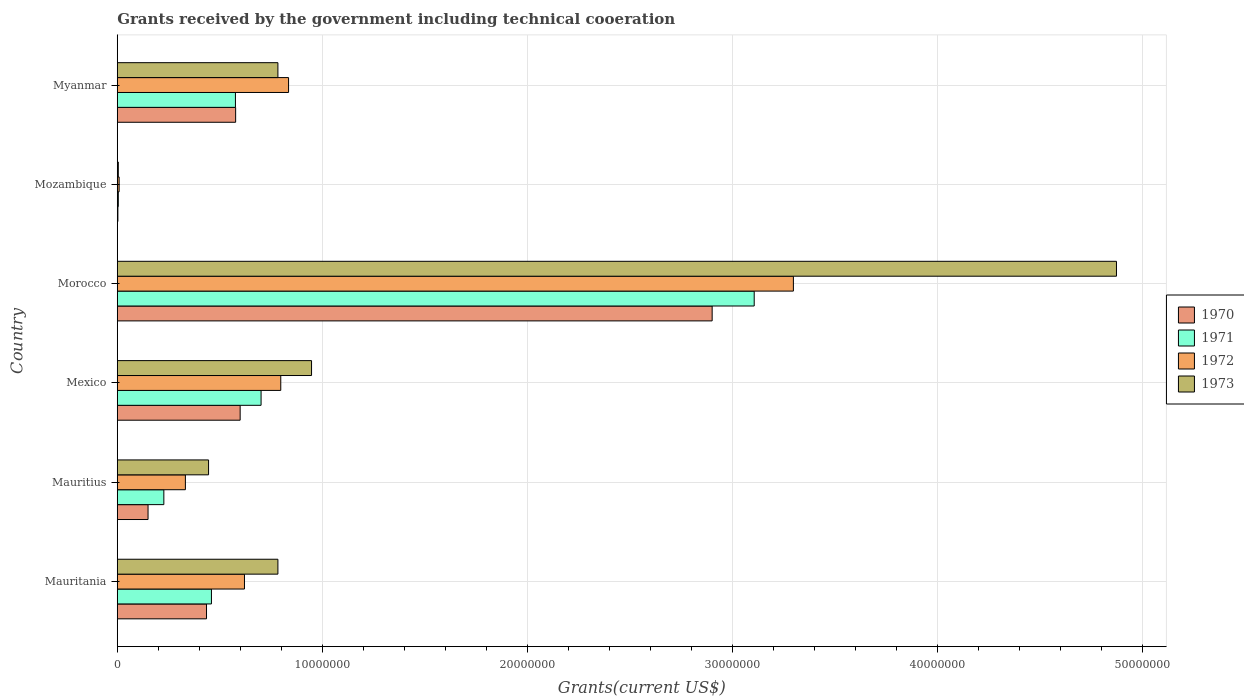How many groups of bars are there?
Keep it short and to the point. 6. Are the number of bars on each tick of the Y-axis equal?
Ensure brevity in your answer.  Yes. What is the label of the 3rd group of bars from the top?
Keep it short and to the point. Morocco. What is the total grants received by the government in 1971 in Mauritania?
Make the answer very short. 4.59e+06. Across all countries, what is the maximum total grants received by the government in 1971?
Offer a terse response. 3.10e+07. In which country was the total grants received by the government in 1972 maximum?
Offer a very short reply. Morocco. In which country was the total grants received by the government in 1971 minimum?
Give a very brief answer. Mozambique. What is the total total grants received by the government in 1971 in the graph?
Ensure brevity in your answer.  5.07e+07. What is the difference between the total grants received by the government in 1973 in Mozambique and that in Myanmar?
Your response must be concise. -7.78e+06. What is the difference between the total grants received by the government in 1973 in Morocco and the total grants received by the government in 1972 in Mauritania?
Keep it short and to the point. 4.25e+07. What is the average total grants received by the government in 1973 per country?
Provide a short and direct response. 1.31e+07. What is the difference between the total grants received by the government in 1972 and total grants received by the government in 1973 in Mexico?
Provide a short and direct response. -1.50e+06. What is the ratio of the total grants received by the government in 1973 in Mauritania to that in Mauritius?
Keep it short and to the point. 1.76. Is the total grants received by the government in 1970 in Mauritius less than that in Mexico?
Your response must be concise. Yes. Is the difference between the total grants received by the government in 1972 in Mauritania and Mauritius greater than the difference between the total grants received by the government in 1973 in Mauritania and Mauritius?
Give a very brief answer. No. What is the difference between the highest and the second highest total grants received by the government in 1970?
Offer a terse response. 2.30e+07. What is the difference between the highest and the lowest total grants received by the government in 1971?
Provide a succinct answer. 3.10e+07. Is the sum of the total grants received by the government in 1970 in Mozambique and Myanmar greater than the maximum total grants received by the government in 1971 across all countries?
Make the answer very short. No. Is it the case that in every country, the sum of the total grants received by the government in 1971 and total grants received by the government in 1970 is greater than the sum of total grants received by the government in 1972 and total grants received by the government in 1973?
Your response must be concise. No. What does the 2nd bar from the bottom in Mauritania represents?
Keep it short and to the point. 1971. Is it the case that in every country, the sum of the total grants received by the government in 1970 and total grants received by the government in 1971 is greater than the total grants received by the government in 1973?
Make the answer very short. No. How many bars are there?
Your answer should be very brief. 24. Are all the bars in the graph horizontal?
Provide a short and direct response. Yes. What is the difference between two consecutive major ticks on the X-axis?
Ensure brevity in your answer.  1.00e+07. Does the graph contain grids?
Your response must be concise. Yes. Where does the legend appear in the graph?
Give a very brief answer. Center right. What is the title of the graph?
Offer a terse response. Grants received by the government including technical cooeration. Does "1971" appear as one of the legend labels in the graph?
Provide a succinct answer. Yes. What is the label or title of the X-axis?
Provide a succinct answer. Grants(current US$). What is the Grants(current US$) in 1970 in Mauritania?
Your answer should be very brief. 4.35e+06. What is the Grants(current US$) in 1971 in Mauritania?
Keep it short and to the point. 4.59e+06. What is the Grants(current US$) in 1972 in Mauritania?
Ensure brevity in your answer.  6.20e+06. What is the Grants(current US$) of 1973 in Mauritania?
Ensure brevity in your answer.  7.83e+06. What is the Grants(current US$) in 1970 in Mauritius?
Provide a short and direct response. 1.50e+06. What is the Grants(current US$) of 1971 in Mauritius?
Your response must be concise. 2.27e+06. What is the Grants(current US$) in 1972 in Mauritius?
Your answer should be compact. 3.32e+06. What is the Grants(current US$) of 1973 in Mauritius?
Keep it short and to the point. 4.45e+06. What is the Grants(current US$) in 1970 in Mexico?
Your answer should be very brief. 5.99e+06. What is the Grants(current US$) of 1971 in Mexico?
Your answer should be compact. 7.01e+06. What is the Grants(current US$) in 1972 in Mexico?
Ensure brevity in your answer.  7.97e+06. What is the Grants(current US$) in 1973 in Mexico?
Give a very brief answer. 9.47e+06. What is the Grants(current US$) of 1970 in Morocco?
Provide a short and direct response. 2.90e+07. What is the Grants(current US$) of 1971 in Morocco?
Your response must be concise. 3.10e+07. What is the Grants(current US$) of 1972 in Morocco?
Offer a very short reply. 3.30e+07. What is the Grants(current US$) in 1973 in Morocco?
Offer a very short reply. 4.87e+07. What is the Grants(current US$) in 1972 in Mozambique?
Your answer should be very brief. 9.00e+04. What is the Grants(current US$) of 1973 in Mozambique?
Provide a succinct answer. 5.00e+04. What is the Grants(current US$) in 1970 in Myanmar?
Your response must be concise. 5.77e+06. What is the Grants(current US$) of 1971 in Myanmar?
Your answer should be compact. 5.76e+06. What is the Grants(current US$) in 1972 in Myanmar?
Provide a succinct answer. 8.35e+06. What is the Grants(current US$) in 1973 in Myanmar?
Ensure brevity in your answer.  7.83e+06. Across all countries, what is the maximum Grants(current US$) of 1970?
Your answer should be very brief. 2.90e+07. Across all countries, what is the maximum Grants(current US$) of 1971?
Your response must be concise. 3.10e+07. Across all countries, what is the maximum Grants(current US$) of 1972?
Make the answer very short. 3.30e+07. Across all countries, what is the maximum Grants(current US$) in 1973?
Give a very brief answer. 4.87e+07. Across all countries, what is the minimum Grants(current US$) of 1972?
Offer a terse response. 9.00e+04. What is the total Grants(current US$) of 1970 in the graph?
Your response must be concise. 4.66e+07. What is the total Grants(current US$) in 1971 in the graph?
Ensure brevity in your answer.  5.07e+07. What is the total Grants(current US$) in 1972 in the graph?
Keep it short and to the point. 5.89e+07. What is the total Grants(current US$) in 1973 in the graph?
Your response must be concise. 7.83e+07. What is the difference between the Grants(current US$) in 1970 in Mauritania and that in Mauritius?
Offer a very short reply. 2.85e+06. What is the difference between the Grants(current US$) in 1971 in Mauritania and that in Mauritius?
Make the answer very short. 2.32e+06. What is the difference between the Grants(current US$) in 1972 in Mauritania and that in Mauritius?
Make the answer very short. 2.88e+06. What is the difference between the Grants(current US$) of 1973 in Mauritania and that in Mauritius?
Your answer should be very brief. 3.38e+06. What is the difference between the Grants(current US$) of 1970 in Mauritania and that in Mexico?
Your response must be concise. -1.64e+06. What is the difference between the Grants(current US$) of 1971 in Mauritania and that in Mexico?
Provide a short and direct response. -2.42e+06. What is the difference between the Grants(current US$) in 1972 in Mauritania and that in Mexico?
Make the answer very short. -1.77e+06. What is the difference between the Grants(current US$) of 1973 in Mauritania and that in Mexico?
Provide a short and direct response. -1.64e+06. What is the difference between the Grants(current US$) in 1970 in Mauritania and that in Morocco?
Make the answer very short. -2.46e+07. What is the difference between the Grants(current US$) of 1971 in Mauritania and that in Morocco?
Your answer should be very brief. -2.65e+07. What is the difference between the Grants(current US$) in 1972 in Mauritania and that in Morocco?
Give a very brief answer. -2.68e+07. What is the difference between the Grants(current US$) in 1973 in Mauritania and that in Morocco?
Offer a terse response. -4.09e+07. What is the difference between the Grants(current US$) of 1970 in Mauritania and that in Mozambique?
Give a very brief answer. 4.32e+06. What is the difference between the Grants(current US$) of 1971 in Mauritania and that in Mozambique?
Keep it short and to the point. 4.54e+06. What is the difference between the Grants(current US$) of 1972 in Mauritania and that in Mozambique?
Provide a succinct answer. 6.11e+06. What is the difference between the Grants(current US$) in 1973 in Mauritania and that in Mozambique?
Make the answer very short. 7.78e+06. What is the difference between the Grants(current US$) of 1970 in Mauritania and that in Myanmar?
Offer a terse response. -1.42e+06. What is the difference between the Grants(current US$) in 1971 in Mauritania and that in Myanmar?
Ensure brevity in your answer.  -1.17e+06. What is the difference between the Grants(current US$) in 1972 in Mauritania and that in Myanmar?
Offer a terse response. -2.15e+06. What is the difference between the Grants(current US$) in 1970 in Mauritius and that in Mexico?
Your answer should be compact. -4.49e+06. What is the difference between the Grants(current US$) of 1971 in Mauritius and that in Mexico?
Provide a succinct answer. -4.74e+06. What is the difference between the Grants(current US$) of 1972 in Mauritius and that in Mexico?
Offer a very short reply. -4.65e+06. What is the difference between the Grants(current US$) of 1973 in Mauritius and that in Mexico?
Offer a very short reply. -5.02e+06. What is the difference between the Grants(current US$) in 1970 in Mauritius and that in Morocco?
Keep it short and to the point. -2.75e+07. What is the difference between the Grants(current US$) of 1971 in Mauritius and that in Morocco?
Ensure brevity in your answer.  -2.88e+07. What is the difference between the Grants(current US$) in 1972 in Mauritius and that in Morocco?
Make the answer very short. -2.96e+07. What is the difference between the Grants(current US$) of 1973 in Mauritius and that in Morocco?
Your answer should be compact. -4.43e+07. What is the difference between the Grants(current US$) of 1970 in Mauritius and that in Mozambique?
Your response must be concise. 1.47e+06. What is the difference between the Grants(current US$) of 1971 in Mauritius and that in Mozambique?
Offer a terse response. 2.22e+06. What is the difference between the Grants(current US$) of 1972 in Mauritius and that in Mozambique?
Your answer should be compact. 3.23e+06. What is the difference between the Grants(current US$) in 1973 in Mauritius and that in Mozambique?
Provide a succinct answer. 4.40e+06. What is the difference between the Grants(current US$) of 1970 in Mauritius and that in Myanmar?
Your response must be concise. -4.27e+06. What is the difference between the Grants(current US$) of 1971 in Mauritius and that in Myanmar?
Your answer should be compact. -3.49e+06. What is the difference between the Grants(current US$) of 1972 in Mauritius and that in Myanmar?
Keep it short and to the point. -5.03e+06. What is the difference between the Grants(current US$) of 1973 in Mauritius and that in Myanmar?
Give a very brief answer. -3.38e+06. What is the difference between the Grants(current US$) of 1970 in Mexico and that in Morocco?
Your answer should be compact. -2.30e+07. What is the difference between the Grants(current US$) of 1971 in Mexico and that in Morocco?
Provide a succinct answer. -2.40e+07. What is the difference between the Grants(current US$) of 1972 in Mexico and that in Morocco?
Your response must be concise. -2.50e+07. What is the difference between the Grants(current US$) in 1973 in Mexico and that in Morocco?
Provide a succinct answer. -3.92e+07. What is the difference between the Grants(current US$) in 1970 in Mexico and that in Mozambique?
Your answer should be very brief. 5.96e+06. What is the difference between the Grants(current US$) in 1971 in Mexico and that in Mozambique?
Provide a short and direct response. 6.96e+06. What is the difference between the Grants(current US$) in 1972 in Mexico and that in Mozambique?
Offer a terse response. 7.88e+06. What is the difference between the Grants(current US$) of 1973 in Mexico and that in Mozambique?
Offer a terse response. 9.42e+06. What is the difference between the Grants(current US$) of 1971 in Mexico and that in Myanmar?
Your answer should be compact. 1.25e+06. What is the difference between the Grants(current US$) of 1972 in Mexico and that in Myanmar?
Provide a short and direct response. -3.80e+05. What is the difference between the Grants(current US$) of 1973 in Mexico and that in Myanmar?
Your answer should be very brief. 1.64e+06. What is the difference between the Grants(current US$) of 1970 in Morocco and that in Mozambique?
Ensure brevity in your answer.  2.90e+07. What is the difference between the Grants(current US$) in 1971 in Morocco and that in Mozambique?
Your answer should be very brief. 3.10e+07. What is the difference between the Grants(current US$) of 1972 in Morocco and that in Mozambique?
Provide a succinct answer. 3.29e+07. What is the difference between the Grants(current US$) in 1973 in Morocco and that in Mozambique?
Make the answer very short. 4.87e+07. What is the difference between the Grants(current US$) in 1970 in Morocco and that in Myanmar?
Offer a very short reply. 2.32e+07. What is the difference between the Grants(current US$) in 1971 in Morocco and that in Myanmar?
Make the answer very short. 2.53e+07. What is the difference between the Grants(current US$) of 1972 in Morocco and that in Myanmar?
Your answer should be very brief. 2.46e+07. What is the difference between the Grants(current US$) of 1973 in Morocco and that in Myanmar?
Give a very brief answer. 4.09e+07. What is the difference between the Grants(current US$) of 1970 in Mozambique and that in Myanmar?
Offer a very short reply. -5.74e+06. What is the difference between the Grants(current US$) in 1971 in Mozambique and that in Myanmar?
Your response must be concise. -5.71e+06. What is the difference between the Grants(current US$) of 1972 in Mozambique and that in Myanmar?
Keep it short and to the point. -8.26e+06. What is the difference between the Grants(current US$) of 1973 in Mozambique and that in Myanmar?
Your answer should be compact. -7.78e+06. What is the difference between the Grants(current US$) in 1970 in Mauritania and the Grants(current US$) in 1971 in Mauritius?
Your answer should be compact. 2.08e+06. What is the difference between the Grants(current US$) of 1970 in Mauritania and the Grants(current US$) of 1972 in Mauritius?
Give a very brief answer. 1.03e+06. What is the difference between the Grants(current US$) in 1970 in Mauritania and the Grants(current US$) in 1973 in Mauritius?
Provide a short and direct response. -1.00e+05. What is the difference between the Grants(current US$) of 1971 in Mauritania and the Grants(current US$) of 1972 in Mauritius?
Your answer should be compact. 1.27e+06. What is the difference between the Grants(current US$) of 1971 in Mauritania and the Grants(current US$) of 1973 in Mauritius?
Give a very brief answer. 1.40e+05. What is the difference between the Grants(current US$) in 1972 in Mauritania and the Grants(current US$) in 1973 in Mauritius?
Your response must be concise. 1.75e+06. What is the difference between the Grants(current US$) of 1970 in Mauritania and the Grants(current US$) of 1971 in Mexico?
Make the answer very short. -2.66e+06. What is the difference between the Grants(current US$) in 1970 in Mauritania and the Grants(current US$) in 1972 in Mexico?
Offer a very short reply. -3.62e+06. What is the difference between the Grants(current US$) of 1970 in Mauritania and the Grants(current US$) of 1973 in Mexico?
Keep it short and to the point. -5.12e+06. What is the difference between the Grants(current US$) of 1971 in Mauritania and the Grants(current US$) of 1972 in Mexico?
Offer a very short reply. -3.38e+06. What is the difference between the Grants(current US$) in 1971 in Mauritania and the Grants(current US$) in 1973 in Mexico?
Offer a very short reply. -4.88e+06. What is the difference between the Grants(current US$) of 1972 in Mauritania and the Grants(current US$) of 1973 in Mexico?
Give a very brief answer. -3.27e+06. What is the difference between the Grants(current US$) of 1970 in Mauritania and the Grants(current US$) of 1971 in Morocco?
Provide a succinct answer. -2.67e+07. What is the difference between the Grants(current US$) in 1970 in Mauritania and the Grants(current US$) in 1972 in Morocco?
Ensure brevity in your answer.  -2.86e+07. What is the difference between the Grants(current US$) of 1970 in Mauritania and the Grants(current US$) of 1973 in Morocco?
Give a very brief answer. -4.44e+07. What is the difference between the Grants(current US$) in 1971 in Mauritania and the Grants(current US$) in 1972 in Morocco?
Offer a terse response. -2.84e+07. What is the difference between the Grants(current US$) in 1971 in Mauritania and the Grants(current US$) in 1973 in Morocco?
Provide a short and direct response. -4.41e+07. What is the difference between the Grants(current US$) of 1972 in Mauritania and the Grants(current US$) of 1973 in Morocco?
Your answer should be very brief. -4.25e+07. What is the difference between the Grants(current US$) in 1970 in Mauritania and the Grants(current US$) in 1971 in Mozambique?
Ensure brevity in your answer.  4.30e+06. What is the difference between the Grants(current US$) of 1970 in Mauritania and the Grants(current US$) of 1972 in Mozambique?
Your response must be concise. 4.26e+06. What is the difference between the Grants(current US$) of 1970 in Mauritania and the Grants(current US$) of 1973 in Mozambique?
Offer a very short reply. 4.30e+06. What is the difference between the Grants(current US$) in 1971 in Mauritania and the Grants(current US$) in 1972 in Mozambique?
Offer a terse response. 4.50e+06. What is the difference between the Grants(current US$) in 1971 in Mauritania and the Grants(current US$) in 1973 in Mozambique?
Your response must be concise. 4.54e+06. What is the difference between the Grants(current US$) in 1972 in Mauritania and the Grants(current US$) in 1973 in Mozambique?
Ensure brevity in your answer.  6.15e+06. What is the difference between the Grants(current US$) in 1970 in Mauritania and the Grants(current US$) in 1971 in Myanmar?
Ensure brevity in your answer.  -1.41e+06. What is the difference between the Grants(current US$) of 1970 in Mauritania and the Grants(current US$) of 1973 in Myanmar?
Ensure brevity in your answer.  -3.48e+06. What is the difference between the Grants(current US$) in 1971 in Mauritania and the Grants(current US$) in 1972 in Myanmar?
Your response must be concise. -3.76e+06. What is the difference between the Grants(current US$) of 1971 in Mauritania and the Grants(current US$) of 1973 in Myanmar?
Provide a short and direct response. -3.24e+06. What is the difference between the Grants(current US$) of 1972 in Mauritania and the Grants(current US$) of 1973 in Myanmar?
Your answer should be compact. -1.63e+06. What is the difference between the Grants(current US$) of 1970 in Mauritius and the Grants(current US$) of 1971 in Mexico?
Give a very brief answer. -5.51e+06. What is the difference between the Grants(current US$) in 1970 in Mauritius and the Grants(current US$) in 1972 in Mexico?
Your response must be concise. -6.47e+06. What is the difference between the Grants(current US$) of 1970 in Mauritius and the Grants(current US$) of 1973 in Mexico?
Make the answer very short. -7.97e+06. What is the difference between the Grants(current US$) in 1971 in Mauritius and the Grants(current US$) in 1972 in Mexico?
Your answer should be very brief. -5.70e+06. What is the difference between the Grants(current US$) of 1971 in Mauritius and the Grants(current US$) of 1973 in Mexico?
Make the answer very short. -7.20e+06. What is the difference between the Grants(current US$) in 1972 in Mauritius and the Grants(current US$) in 1973 in Mexico?
Your answer should be compact. -6.15e+06. What is the difference between the Grants(current US$) of 1970 in Mauritius and the Grants(current US$) of 1971 in Morocco?
Make the answer very short. -2.96e+07. What is the difference between the Grants(current US$) in 1970 in Mauritius and the Grants(current US$) in 1972 in Morocco?
Provide a short and direct response. -3.15e+07. What is the difference between the Grants(current US$) in 1970 in Mauritius and the Grants(current US$) in 1973 in Morocco?
Give a very brief answer. -4.72e+07. What is the difference between the Grants(current US$) of 1971 in Mauritius and the Grants(current US$) of 1972 in Morocco?
Offer a terse response. -3.07e+07. What is the difference between the Grants(current US$) of 1971 in Mauritius and the Grants(current US$) of 1973 in Morocco?
Your response must be concise. -4.64e+07. What is the difference between the Grants(current US$) in 1972 in Mauritius and the Grants(current US$) in 1973 in Morocco?
Provide a succinct answer. -4.54e+07. What is the difference between the Grants(current US$) in 1970 in Mauritius and the Grants(current US$) in 1971 in Mozambique?
Offer a very short reply. 1.45e+06. What is the difference between the Grants(current US$) in 1970 in Mauritius and the Grants(current US$) in 1972 in Mozambique?
Keep it short and to the point. 1.41e+06. What is the difference between the Grants(current US$) of 1970 in Mauritius and the Grants(current US$) of 1973 in Mozambique?
Your answer should be very brief. 1.45e+06. What is the difference between the Grants(current US$) of 1971 in Mauritius and the Grants(current US$) of 1972 in Mozambique?
Ensure brevity in your answer.  2.18e+06. What is the difference between the Grants(current US$) in 1971 in Mauritius and the Grants(current US$) in 1973 in Mozambique?
Ensure brevity in your answer.  2.22e+06. What is the difference between the Grants(current US$) of 1972 in Mauritius and the Grants(current US$) of 1973 in Mozambique?
Offer a very short reply. 3.27e+06. What is the difference between the Grants(current US$) of 1970 in Mauritius and the Grants(current US$) of 1971 in Myanmar?
Provide a short and direct response. -4.26e+06. What is the difference between the Grants(current US$) in 1970 in Mauritius and the Grants(current US$) in 1972 in Myanmar?
Give a very brief answer. -6.85e+06. What is the difference between the Grants(current US$) of 1970 in Mauritius and the Grants(current US$) of 1973 in Myanmar?
Ensure brevity in your answer.  -6.33e+06. What is the difference between the Grants(current US$) in 1971 in Mauritius and the Grants(current US$) in 1972 in Myanmar?
Offer a terse response. -6.08e+06. What is the difference between the Grants(current US$) of 1971 in Mauritius and the Grants(current US$) of 1973 in Myanmar?
Provide a short and direct response. -5.56e+06. What is the difference between the Grants(current US$) in 1972 in Mauritius and the Grants(current US$) in 1973 in Myanmar?
Provide a succinct answer. -4.51e+06. What is the difference between the Grants(current US$) in 1970 in Mexico and the Grants(current US$) in 1971 in Morocco?
Your answer should be compact. -2.51e+07. What is the difference between the Grants(current US$) in 1970 in Mexico and the Grants(current US$) in 1972 in Morocco?
Provide a short and direct response. -2.70e+07. What is the difference between the Grants(current US$) in 1970 in Mexico and the Grants(current US$) in 1973 in Morocco?
Your answer should be very brief. -4.27e+07. What is the difference between the Grants(current US$) of 1971 in Mexico and the Grants(current US$) of 1972 in Morocco?
Your answer should be very brief. -2.60e+07. What is the difference between the Grants(current US$) in 1971 in Mexico and the Grants(current US$) in 1973 in Morocco?
Keep it short and to the point. -4.17e+07. What is the difference between the Grants(current US$) of 1972 in Mexico and the Grants(current US$) of 1973 in Morocco?
Provide a succinct answer. -4.07e+07. What is the difference between the Grants(current US$) of 1970 in Mexico and the Grants(current US$) of 1971 in Mozambique?
Give a very brief answer. 5.94e+06. What is the difference between the Grants(current US$) in 1970 in Mexico and the Grants(current US$) in 1972 in Mozambique?
Provide a succinct answer. 5.90e+06. What is the difference between the Grants(current US$) in 1970 in Mexico and the Grants(current US$) in 1973 in Mozambique?
Your response must be concise. 5.94e+06. What is the difference between the Grants(current US$) of 1971 in Mexico and the Grants(current US$) of 1972 in Mozambique?
Keep it short and to the point. 6.92e+06. What is the difference between the Grants(current US$) in 1971 in Mexico and the Grants(current US$) in 1973 in Mozambique?
Keep it short and to the point. 6.96e+06. What is the difference between the Grants(current US$) in 1972 in Mexico and the Grants(current US$) in 1973 in Mozambique?
Offer a very short reply. 7.92e+06. What is the difference between the Grants(current US$) in 1970 in Mexico and the Grants(current US$) in 1972 in Myanmar?
Offer a very short reply. -2.36e+06. What is the difference between the Grants(current US$) of 1970 in Mexico and the Grants(current US$) of 1973 in Myanmar?
Your answer should be very brief. -1.84e+06. What is the difference between the Grants(current US$) of 1971 in Mexico and the Grants(current US$) of 1972 in Myanmar?
Make the answer very short. -1.34e+06. What is the difference between the Grants(current US$) of 1971 in Mexico and the Grants(current US$) of 1973 in Myanmar?
Your answer should be very brief. -8.20e+05. What is the difference between the Grants(current US$) in 1972 in Mexico and the Grants(current US$) in 1973 in Myanmar?
Your response must be concise. 1.40e+05. What is the difference between the Grants(current US$) in 1970 in Morocco and the Grants(current US$) in 1971 in Mozambique?
Give a very brief answer. 2.90e+07. What is the difference between the Grants(current US$) of 1970 in Morocco and the Grants(current US$) of 1972 in Mozambique?
Your answer should be very brief. 2.89e+07. What is the difference between the Grants(current US$) in 1970 in Morocco and the Grants(current US$) in 1973 in Mozambique?
Your answer should be very brief. 2.90e+07. What is the difference between the Grants(current US$) of 1971 in Morocco and the Grants(current US$) of 1972 in Mozambique?
Make the answer very short. 3.10e+07. What is the difference between the Grants(current US$) in 1971 in Morocco and the Grants(current US$) in 1973 in Mozambique?
Offer a very short reply. 3.10e+07. What is the difference between the Grants(current US$) in 1972 in Morocco and the Grants(current US$) in 1973 in Mozambique?
Make the answer very short. 3.29e+07. What is the difference between the Grants(current US$) of 1970 in Morocco and the Grants(current US$) of 1971 in Myanmar?
Offer a terse response. 2.32e+07. What is the difference between the Grants(current US$) in 1970 in Morocco and the Grants(current US$) in 1972 in Myanmar?
Your response must be concise. 2.06e+07. What is the difference between the Grants(current US$) of 1970 in Morocco and the Grants(current US$) of 1973 in Myanmar?
Your answer should be very brief. 2.12e+07. What is the difference between the Grants(current US$) in 1971 in Morocco and the Grants(current US$) in 1972 in Myanmar?
Offer a terse response. 2.27e+07. What is the difference between the Grants(current US$) of 1971 in Morocco and the Grants(current US$) of 1973 in Myanmar?
Your response must be concise. 2.32e+07. What is the difference between the Grants(current US$) in 1972 in Morocco and the Grants(current US$) in 1973 in Myanmar?
Provide a short and direct response. 2.51e+07. What is the difference between the Grants(current US$) of 1970 in Mozambique and the Grants(current US$) of 1971 in Myanmar?
Your answer should be very brief. -5.73e+06. What is the difference between the Grants(current US$) in 1970 in Mozambique and the Grants(current US$) in 1972 in Myanmar?
Offer a terse response. -8.32e+06. What is the difference between the Grants(current US$) in 1970 in Mozambique and the Grants(current US$) in 1973 in Myanmar?
Your answer should be compact. -7.80e+06. What is the difference between the Grants(current US$) of 1971 in Mozambique and the Grants(current US$) of 1972 in Myanmar?
Ensure brevity in your answer.  -8.30e+06. What is the difference between the Grants(current US$) in 1971 in Mozambique and the Grants(current US$) in 1973 in Myanmar?
Offer a very short reply. -7.78e+06. What is the difference between the Grants(current US$) of 1972 in Mozambique and the Grants(current US$) of 1973 in Myanmar?
Offer a very short reply. -7.74e+06. What is the average Grants(current US$) of 1970 per country?
Offer a very short reply. 7.77e+06. What is the average Grants(current US$) in 1971 per country?
Offer a terse response. 8.46e+06. What is the average Grants(current US$) in 1972 per country?
Ensure brevity in your answer.  9.82e+06. What is the average Grants(current US$) in 1973 per country?
Offer a terse response. 1.31e+07. What is the difference between the Grants(current US$) in 1970 and Grants(current US$) in 1971 in Mauritania?
Ensure brevity in your answer.  -2.40e+05. What is the difference between the Grants(current US$) of 1970 and Grants(current US$) of 1972 in Mauritania?
Provide a short and direct response. -1.85e+06. What is the difference between the Grants(current US$) in 1970 and Grants(current US$) in 1973 in Mauritania?
Make the answer very short. -3.48e+06. What is the difference between the Grants(current US$) in 1971 and Grants(current US$) in 1972 in Mauritania?
Your answer should be compact. -1.61e+06. What is the difference between the Grants(current US$) of 1971 and Grants(current US$) of 1973 in Mauritania?
Ensure brevity in your answer.  -3.24e+06. What is the difference between the Grants(current US$) of 1972 and Grants(current US$) of 1973 in Mauritania?
Keep it short and to the point. -1.63e+06. What is the difference between the Grants(current US$) of 1970 and Grants(current US$) of 1971 in Mauritius?
Your response must be concise. -7.70e+05. What is the difference between the Grants(current US$) in 1970 and Grants(current US$) in 1972 in Mauritius?
Your response must be concise. -1.82e+06. What is the difference between the Grants(current US$) of 1970 and Grants(current US$) of 1973 in Mauritius?
Keep it short and to the point. -2.95e+06. What is the difference between the Grants(current US$) in 1971 and Grants(current US$) in 1972 in Mauritius?
Give a very brief answer. -1.05e+06. What is the difference between the Grants(current US$) in 1971 and Grants(current US$) in 1973 in Mauritius?
Keep it short and to the point. -2.18e+06. What is the difference between the Grants(current US$) in 1972 and Grants(current US$) in 1973 in Mauritius?
Your answer should be very brief. -1.13e+06. What is the difference between the Grants(current US$) in 1970 and Grants(current US$) in 1971 in Mexico?
Give a very brief answer. -1.02e+06. What is the difference between the Grants(current US$) of 1970 and Grants(current US$) of 1972 in Mexico?
Your response must be concise. -1.98e+06. What is the difference between the Grants(current US$) of 1970 and Grants(current US$) of 1973 in Mexico?
Your answer should be very brief. -3.48e+06. What is the difference between the Grants(current US$) in 1971 and Grants(current US$) in 1972 in Mexico?
Offer a terse response. -9.60e+05. What is the difference between the Grants(current US$) of 1971 and Grants(current US$) of 1973 in Mexico?
Provide a succinct answer. -2.46e+06. What is the difference between the Grants(current US$) in 1972 and Grants(current US$) in 1973 in Mexico?
Your answer should be compact. -1.50e+06. What is the difference between the Grants(current US$) in 1970 and Grants(current US$) in 1971 in Morocco?
Keep it short and to the point. -2.05e+06. What is the difference between the Grants(current US$) in 1970 and Grants(current US$) in 1972 in Morocco?
Offer a terse response. -3.96e+06. What is the difference between the Grants(current US$) of 1970 and Grants(current US$) of 1973 in Morocco?
Keep it short and to the point. -1.97e+07. What is the difference between the Grants(current US$) in 1971 and Grants(current US$) in 1972 in Morocco?
Your response must be concise. -1.91e+06. What is the difference between the Grants(current US$) in 1971 and Grants(current US$) in 1973 in Morocco?
Give a very brief answer. -1.77e+07. What is the difference between the Grants(current US$) in 1972 and Grants(current US$) in 1973 in Morocco?
Ensure brevity in your answer.  -1.58e+07. What is the difference between the Grants(current US$) in 1970 and Grants(current US$) in 1972 in Mozambique?
Your answer should be compact. -6.00e+04. What is the difference between the Grants(current US$) in 1970 and Grants(current US$) in 1972 in Myanmar?
Offer a terse response. -2.58e+06. What is the difference between the Grants(current US$) of 1970 and Grants(current US$) of 1973 in Myanmar?
Keep it short and to the point. -2.06e+06. What is the difference between the Grants(current US$) of 1971 and Grants(current US$) of 1972 in Myanmar?
Offer a very short reply. -2.59e+06. What is the difference between the Grants(current US$) in 1971 and Grants(current US$) in 1973 in Myanmar?
Keep it short and to the point. -2.07e+06. What is the difference between the Grants(current US$) of 1972 and Grants(current US$) of 1973 in Myanmar?
Your answer should be compact. 5.20e+05. What is the ratio of the Grants(current US$) of 1971 in Mauritania to that in Mauritius?
Provide a short and direct response. 2.02. What is the ratio of the Grants(current US$) of 1972 in Mauritania to that in Mauritius?
Your response must be concise. 1.87. What is the ratio of the Grants(current US$) in 1973 in Mauritania to that in Mauritius?
Your answer should be very brief. 1.76. What is the ratio of the Grants(current US$) in 1970 in Mauritania to that in Mexico?
Keep it short and to the point. 0.73. What is the ratio of the Grants(current US$) in 1971 in Mauritania to that in Mexico?
Offer a terse response. 0.65. What is the ratio of the Grants(current US$) of 1972 in Mauritania to that in Mexico?
Keep it short and to the point. 0.78. What is the ratio of the Grants(current US$) of 1973 in Mauritania to that in Mexico?
Ensure brevity in your answer.  0.83. What is the ratio of the Grants(current US$) of 1971 in Mauritania to that in Morocco?
Your answer should be compact. 0.15. What is the ratio of the Grants(current US$) in 1972 in Mauritania to that in Morocco?
Provide a succinct answer. 0.19. What is the ratio of the Grants(current US$) in 1973 in Mauritania to that in Morocco?
Keep it short and to the point. 0.16. What is the ratio of the Grants(current US$) in 1970 in Mauritania to that in Mozambique?
Your answer should be very brief. 145. What is the ratio of the Grants(current US$) in 1971 in Mauritania to that in Mozambique?
Ensure brevity in your answer.  91.8. What is the ratio of the Grants(current US$) in 1972 in Mauritania to that in Mozambique?
Your response must be concise. 68.89. What is the ratio of the Grants(current US$) of 1973 in Mauritania to that in Mozambique?
Offer a terse response. 156.6. What is the ratio of the Grants(current US$) in 1970 in Mauritania to that in Myanmar?
Ensure brevity in your answer.  0.75. What is the ratio of the Grants(current US$) in 1971 in Mauritania to that in Myanmar?
Give a very brief answer. 0.8. What is the ratio of the Grants(current US$) in 1972 in Mauritania to that in Myanmar?
Make the answer very short. 0.74. What is the ratio of the Grants(current US$) in 1970 in Mauritius to that in Mexico?
Give a very brief answer. 0.25. What is the ratio of the Grants(current US$) in 1971 in Mauritius to that in Mexico?
Your answer should be compact. 0.32. What is the ratio of the Grants(current US$) of 1972 in Mauritius to that in Mexico?
Give a very brief answer. 0.42. What is the ratio of the Grants(current US$) in 1973 in Mauritius to that in Mexico?
Offer a very short reply. 0.47. What is the ratio of the Grants(current US$) of 1970 in Mauritius to that in Morocco?
Offer a very short reply. 0.05. What is the ratio of the Grants(current US$) in 1971 in Mauritius to that in Morocco?
Your answer should be very brief. 0.07. What is the ratio of the Grants(current US$) of 1972 in Mauritius to that in Morocco?
Your answer should be very brief. 0.1. What is the ratio of the Grants(current US$) in 1973 in Mauritius to that in Morocco?
Provide a short and direct response. 0.09. What is the ratio of the Grants(current US$) in 1971 in Mauritius to that in Mozambique?
Give a very brief answer. 45.4. What is the ratio of the Grants(current US$) in 1972 in Mauritius to that in Mozambique?
Make the answer very short. 36.89. What is the ratio of the Grants(current US$) of 1973 in Mauritius to that in Mozambique?
Your answer should be compact. 89. What is the ratio of the Grants(current US$) in 1970 in Mauritius to that in Myanmar?
Give a very brief answer. 0.26. What is the ratio of the Grants(current US$) of 1971 in Mauritius to that in Myanmar?
Provide a short and direct response. 0.39. What is the ratio of the Grants(current US$) of 1972 in Mauritius to that in Myanmar?
Offer a terse response. 0.4. What is the ratio of the Grants(current US$) in 1973 in Mauritius to that in Myanmar?
Your answer should be very brief. 0.57. What is the ratio of the Grants(current US$) of 1970 in Mexico to that in Morocco?
Keep it short and to the point. 0.21. What is the ratio of the Grants(current US$) in 1971 in Mexico to that in Morocco?
Your response must be concise. 0.23. What is the ratio of the Grants(current US$) of 1972 in Mexico to that in Morocco?
Offer a terse response. 0.24. What is the ratio of the Grants(current US$) of 1973 in Mexico to that in Morocco?
Offer a terse response. 0.19. What is the ratio of the Grants(current US$) of 1970 in Mexico to that in Mozambique?
Provide a short and direct response. 199.67. What is the ratio of the Grants(current US$) in 1971 in Mexico to that in Mozambique?
Provide a succinct answer. 140.2. What is the ratio of the Grants(current US$) of 1972 in Mexico to that in Mozambique?
Give a very brief answer. 88.56. What is the ratio of the Grants(current US$) of 1973 in Mexico to that in Mozambique?
Your answer should be compact. 189.4. What is the ratio of the Grants(current US$) in 1970 in Mexico to that in Myanmar?
Provide a short and direct response. 1.04. What is the ratio of the Grants(current US$) in 1971 in Mexico to that in Myanmar?
Provide a succinct answer. 1.22. What is the ratio of the Grants(current US$) of 1972 in Mexico to that in Myanmar?
Provide a succinct answer. 0.95. What is the ratio of the Grants(current US$) in 1973 in Mexico to that in Myanmar?
Ensure brevity in your answer.  1.21. What is the ratio of the Grants(current US$) of 1970 in Morocco to that in Mozambique?
Provide a succinct answer. 966.67. What is the ratio of the Grants(current US$) of 1971 in Morocco to that in Mozambique?
Your answer should be compact. 621. What is the ratio of the Grants(current US$) of 1972 in Morocco to that in Mozambique?
Ensure brevity in your answer.  366.22. What is the ratio of the Grants(current US$) of 1973 in Morocco to that in Mozambique?
Your response must be concise. 974.2. What is the ratio of the Grants(current US$) of 1970 in Morocco to that in Myanmar?
Offer a very short reply. 5.03. What is the ratio of the Grants(current US$) of 1971 in Morocco to that in Myanmar?
Ensure brevity in your answer.  5.39. What is the ratio of the Grants(current US$) in 1972 in Morocco to that in Myanmar?
Ensure brevity in your answer.  3.95. What is the ratio of the Grants(current US$) of 1973 in Morocco to that in Myanmar?
Your answer should be compact. 6.22. What is the ratio of the Grants(current US$) of 1970 in Mozambique to that in Myanmar?
Keep it short and to the point. 0.01. What is the ratio of the Grants(current US$) in 1971 in Mozambique to that in Myanmar?
Make the answer very short. 0.01. What is the ratio of the Grants(current US$) in 1972 in Mozambique to that in Myanmar?
Give a very brief answer. 0.01. What is the ratio of the Grants(current US$) of 1973 in Mozambique to that in Myanmar?
Ensure brevity in your answer.  0.01. What is the difference between the highest and the second highest Grants(current US$) in 1970?
Give a very brief answer. 2.30e+07. What is the difference between the highest and the second highest Grants(current US$) in 1971?
Provide a short and direct response. 2.40e+07. What is the difference between the highest and the second highest Grants(current US$) of 1972?
Keep it short and to the point. 2.46e+07. What is the difference between the highest and the second highest Grants(current US$) of 1973?
Provide a short and direct response. 3.92e+07. What is the difference between the highest and the lowest Grants(current US$) in 1970?
Offer a terse response. 2.90e+07. What is the difference between the highest and the lowest Grants(current US$) of 1971?
Your response must be concise. 3.10e+07. What is the difference between the highest and the lowest Grants(current US$) of 1972?
Ensure brevity in your answer.  3.29e+07. What is the difference between the highest and the lowest Grants(current US$) in 1973?
Offer a terse response. 4.87e+07. 